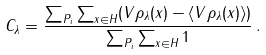<formula> <loc_0><loc_0><loc_500><loc_500>C _ { \lambda } = \frac { \sum _ { P _ { i } } \sum _ { x \in H } ( V \rho _ { \lambda } ( x ) - \langle V \rho _ { \lambda } ( x ) \rangle ) } { \sum _ { P _ { i } } \sum _ { x \in H } 1 } \, .</formula> 